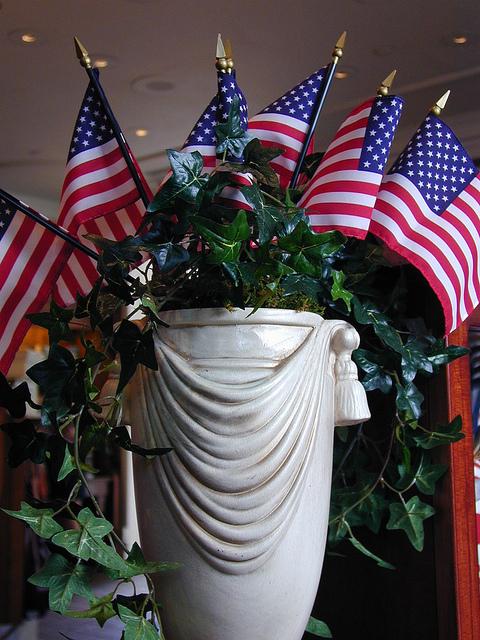What country do the flags represent?
Be succinct. Usa. How many red stripes does each flag have?
Concise answer only. 7. How many flags are there?
Short answer required. 6. 